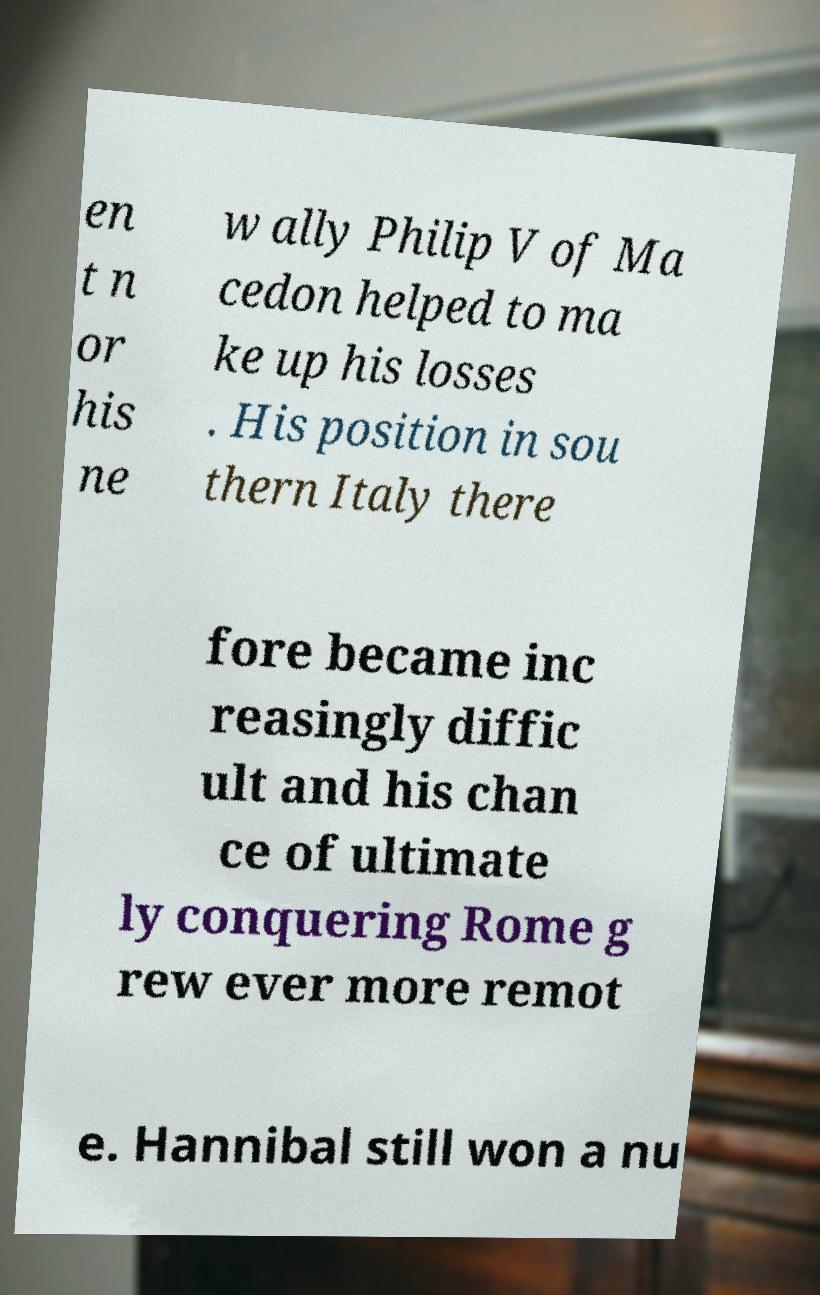Could you assist in decoding the text presented in this image and type it out clearly? en t n or his ne w ally Philip V of Ma cedon helped to ma ke up his losses . His position in sou thern Italy there fore became inc reasingly diffic ult and his chan ce of ultimate ly conquering Rome g rew ever more remot e. Hannibal still won a nu 